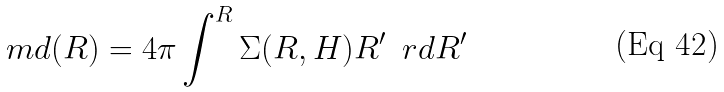Convert formula to latex. <formula><loc_0><loc_0><loc_500><loc_500>\ m d ( R ) = 4 \pi \int ^ { R } { \Sigma ( R , H ) R ^ { \prime } \, { \ r d } R ^ { \prime } }</formula> 